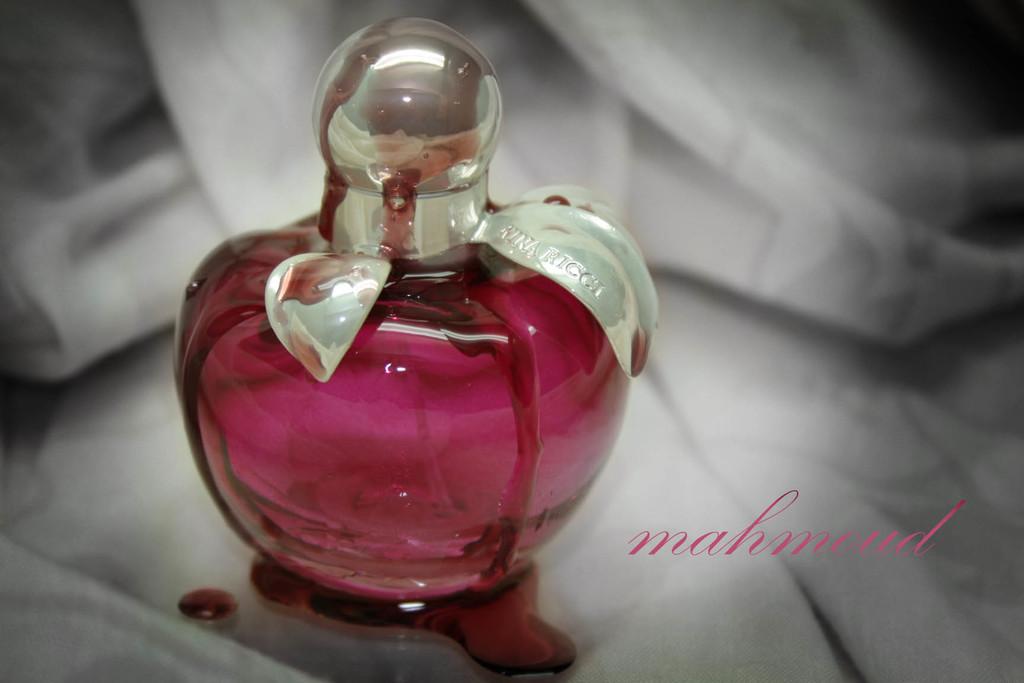What is the brand name in pink?
Your answer should be compact. Mahmoud. 